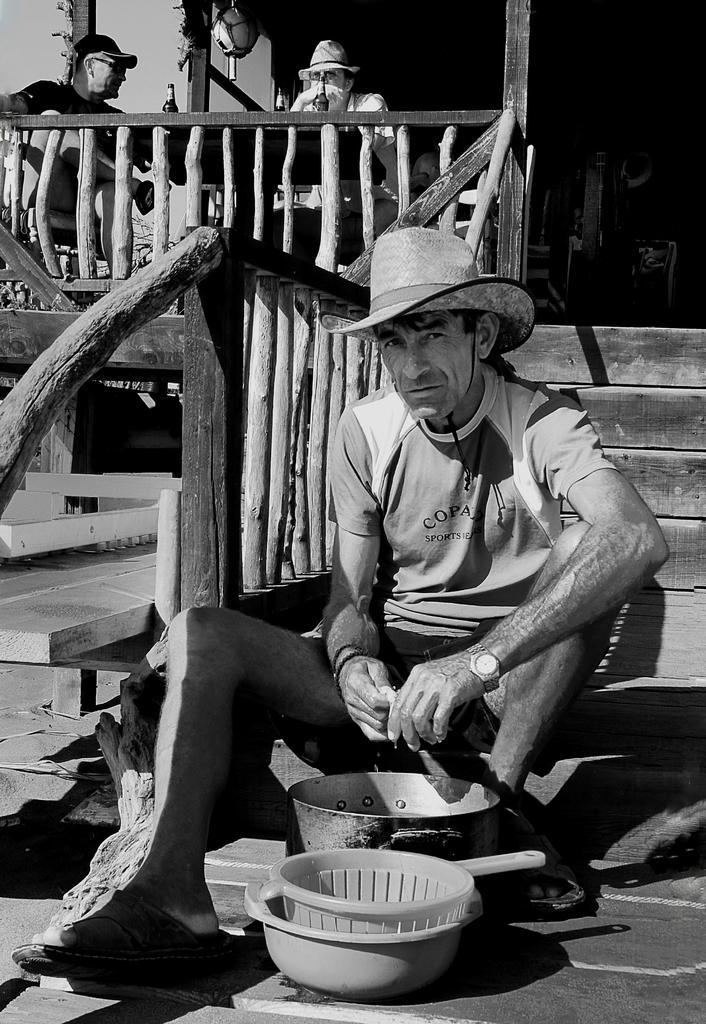How would you summarize this image in a sentence or two? This is a black and white picture. Here we can see a man sitting on a platform and he wore a hat. Here we can see a bowl and baskets. In the background we can see two persons are sitting on the chairs. There is a table. On the table there are bottles. Here we can see railing. 